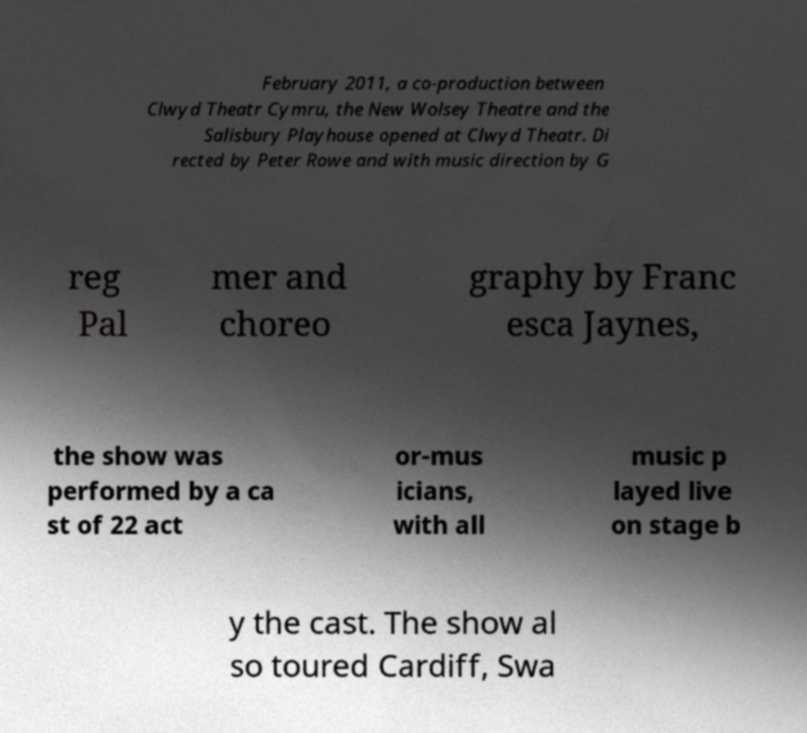Please read and relay the text visible in this image. What does it say? February 2011, a co-production between Clwyd Theatr Cymru, the New Wolsey Theatre and the Salisbury Playhouse opened at Clwyd Theatr. Di rected by Peter Rowe and with music direction by G reg Pal mer and choreo graphy by Franc esca Jaynes, the show was performed by a ca st of 22 act or-mus icians, with all music p layed live on stage b y the cast. The show al so toured Cardiff, Swa 